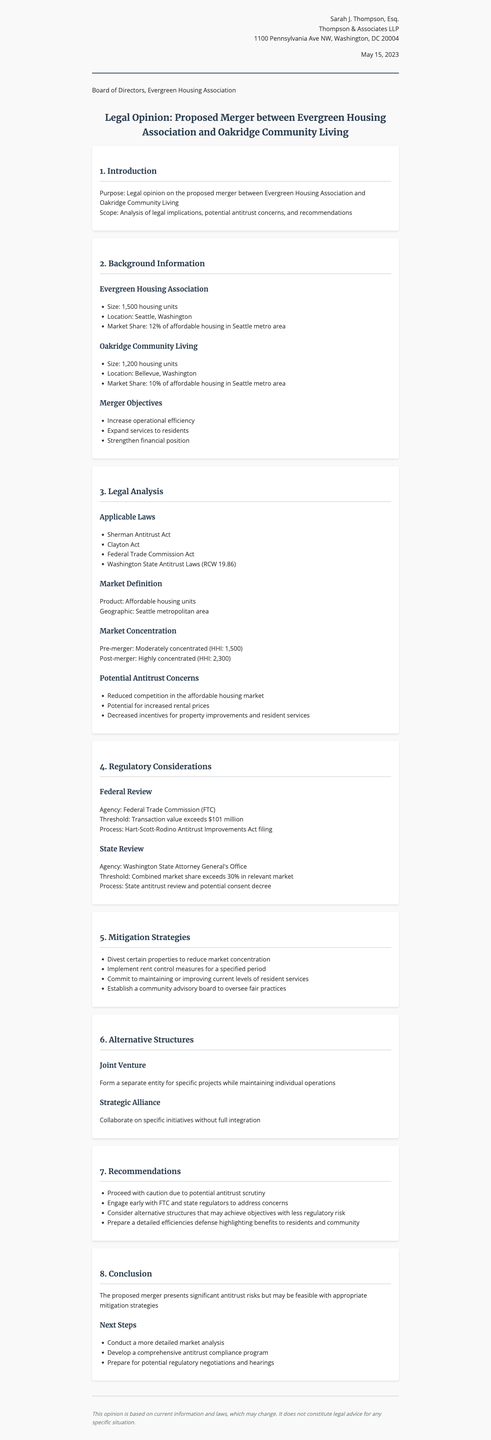What is the sender's name? The sender's name is listed in the letter header section, which states "Sarah J. Thompson, Esq."
Answer: Sarah J. Thompson, Esq What is the size of Evergreen Housing Association? The size is mentioned in the background information section regarding Evergreen Housing Association.
Answer: 1,500 housing units What are the applicable laws referenced in the legal analysis? The document lists applicable laws in the legal analysis section, including several key acts.
Answer: Sherman Antitrust Act, Clayton Act, Federal Trade Commission Act, Washington State Antitrust Laws What is the post-merger HHI? The post-merger HHI is found in the market concentration subsection of the legal analysis.
Answer: 2,300 What is one potential antitrust concern mentioned? The document lists concerns about the merger in the legal analysis section, asking for specific examples of these concerns.
Answer: Reduced competition in the affordable housing market What mitigation strategy is suggested for the merger? The mitigation strategies are outlined in a dedicated section of the document, and any number of strategies can be used as examples.
Answer: Divest certain properties to reduce market concentration What is one of the merger objectives? The objectives for the merger are listed in the background information section, and any objective can be mentioned.
Answer: Increase operational efficiency What is the date of the letter? The date of the letter is specified clearly in the letter header section.
Answer: May 15, 2023 What is the recommendation about engaging regulators? Recommendations for engagement with regulators can be found in the recommendations section towards the end of the document.
Answer: Engage early with FTC and state regulators to address concerns 